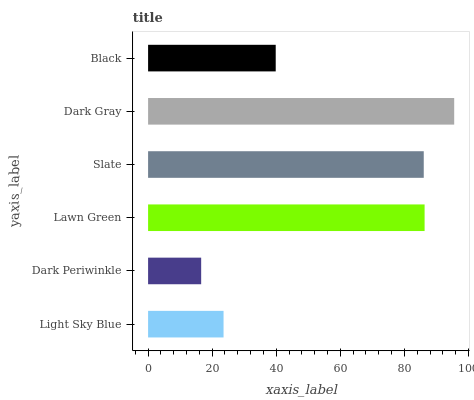Is Dark Periwinkle the minimum?
Answer yes or no. Yes. Is Dark Gray the maximum?
Answer yes or no. Yes. Is Lawn Green the minimum?
Answer yes or no. No. Is Lawn Green the maximum?
Answer yes or no. No. Is Lawn Green greater than Dark Periwinkle?
Answer yes or no. Yes. Is Dark Periwinkle less than Lawn Green?
Answer yes or no. Yes. Is Dark Periwinkle greater than Lawn Green?
Answer yes or no. No. Is Lawn Green less than Dark Periwinkle?
Answer yes or no. No. Is Slate the high median?
Answer yes or no. Yes. Is Black the low median?
Answer yes or no. Yes. Is Lawn Green the high median?
Answer yes or no. No. Is Dark Periwinkle the low median?
Answer yes or no. No. 